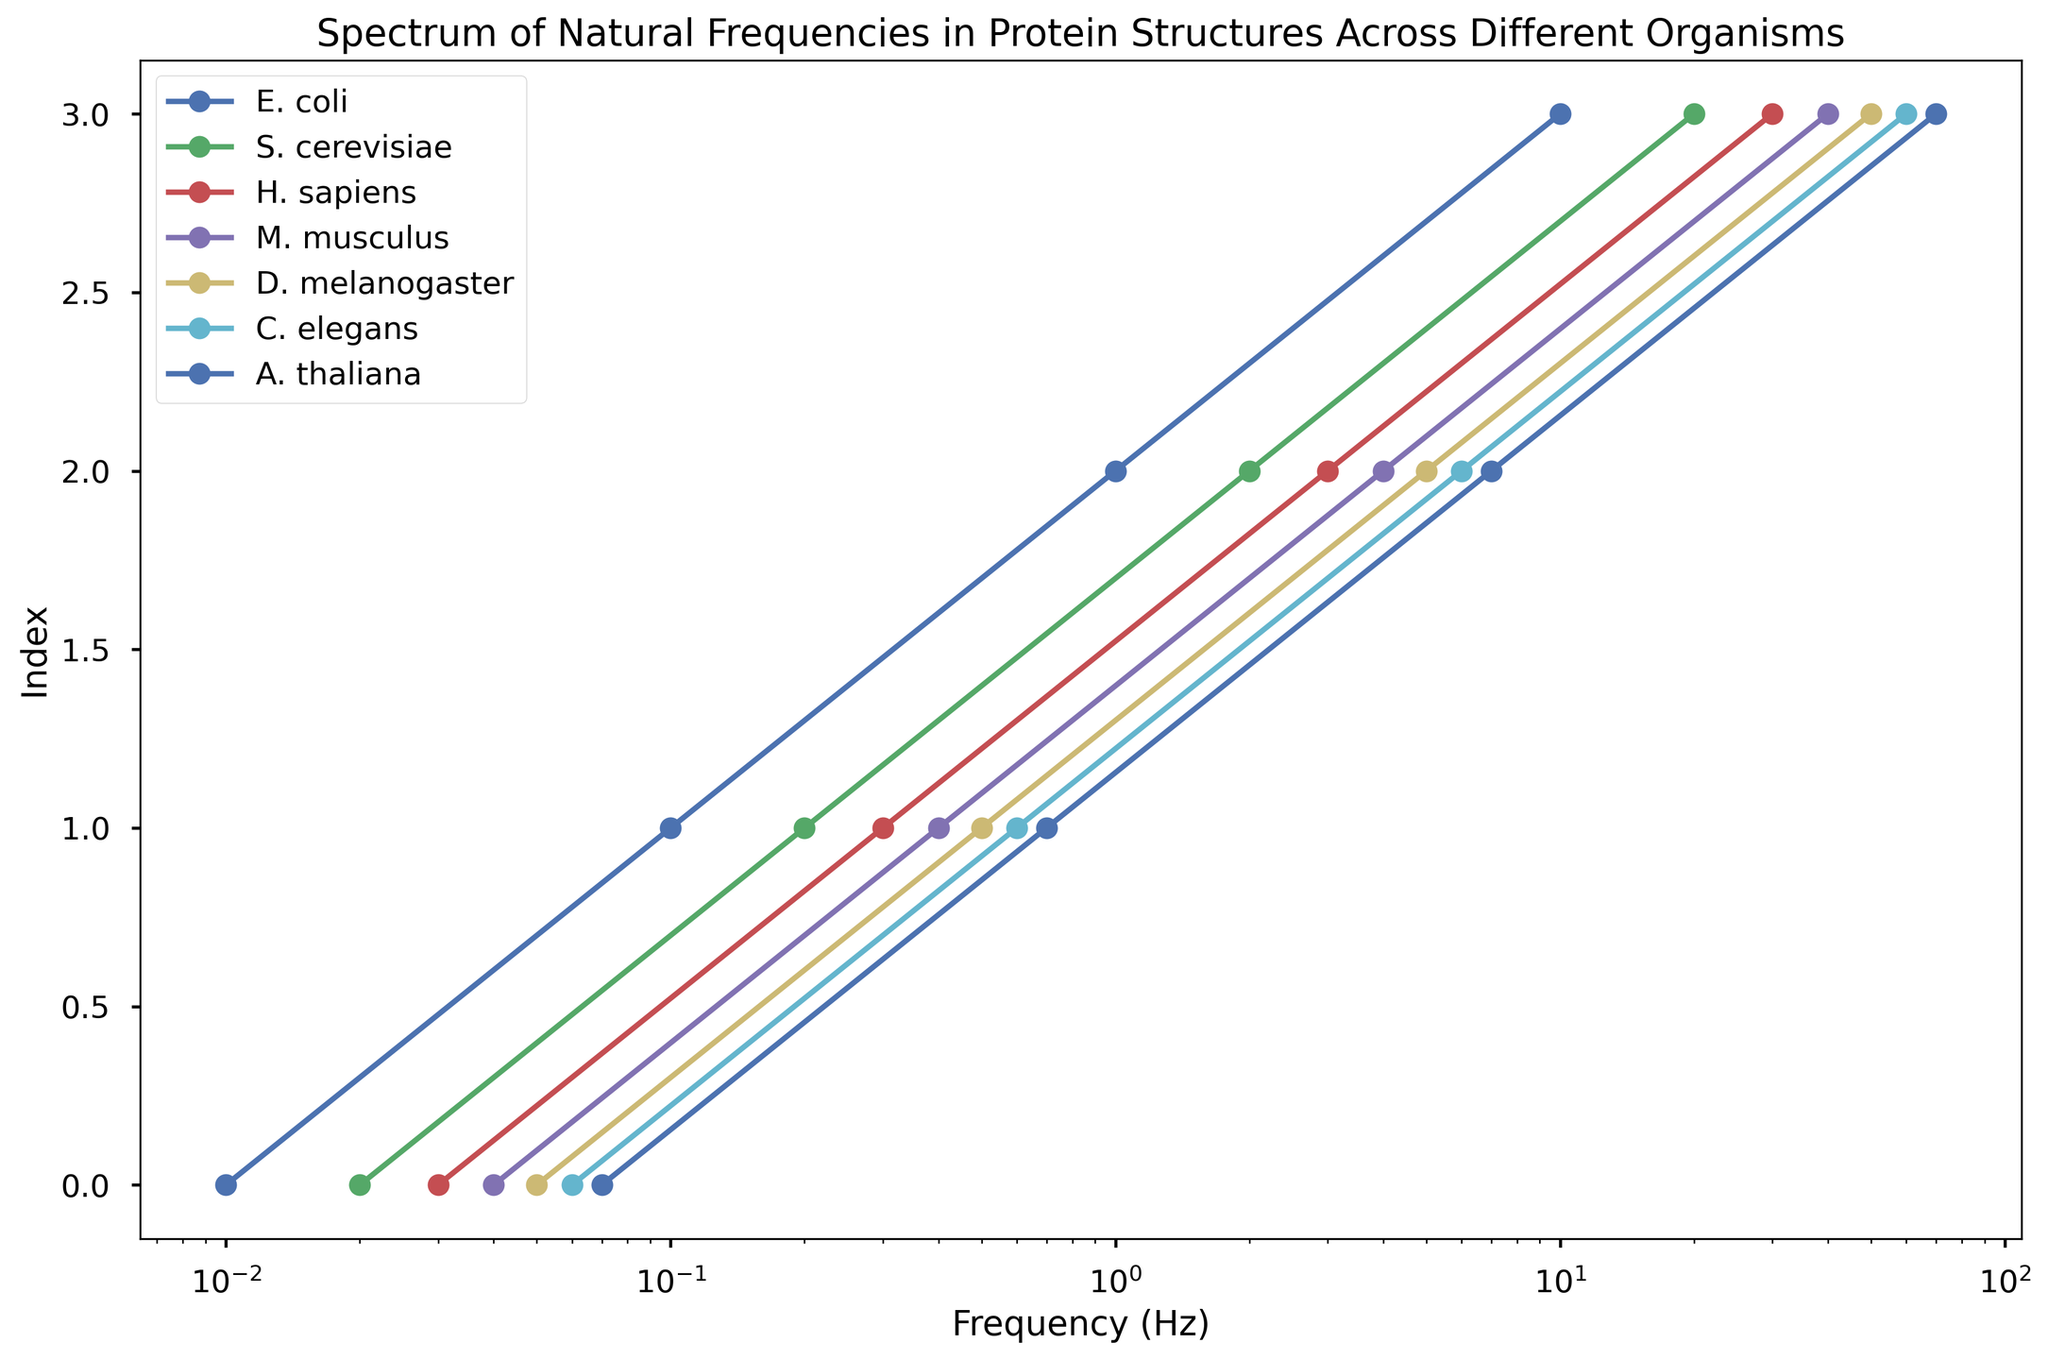Which organism has the highest frequency value represented in the plot? Identify the curves for each organism on the plot and find the one that reaches the highest frequency value on the x-axis. D. melanogaster's plot reaches the highest value at 50 Hz.
Answer: D. melanogaster Which two organisms have frequencies that differ the most at their highest values? Compare the highest frequency values for all organisms plotted on the x-axis. D. melanogaster and A. thaliana differ the most as their highest values are 50 Hz and 70 Hz respectively, resulting in a difference of 20 Hz.
Answer: D. melanogaster and A. thaliana Do any organisms share the same frequency values on the plot? Inspect the plots for each organism on the graph. E. coli and S. cerevisiae share frequency values at 0.1 Hz and 1 Hz.
Answer: E. coli and S. cerevisiae Which organism's frequency distribution appears most compressed on the log scale? On a logarithmic scale, a compressed distribution will show points closer together. E. coli's distribution appears most compressed as its points are closely situated at 0.01 Hz, 0.1 Hz, 1 Hz, and 10 Hz.
Answer: E. coli Which organism has the least number of frequencies plotted on the graph? Count the number of markers for each organism. Each organism has an equal number of frequencies plotted, i.e., 4 frequencies each.
Answer: None (all equal) Is there any organism whose frequency values increase consistently by the same factor? Examine each organism's frequency values on the x-axis and determine if they increase by a constant multiplicative factor. E. coli’s values increase by a factor of 10 (0.01, 0.1, 1, 10).
Answer: E. coli Between S. cerevisiae and C. elegans, which organism shows a higher minimum frequency? Compare the minimum frequency values for S. cerevisiae (0.02 Hz) and C. elegans (0.06 Hz). C. elegans has a higher minimum frequency value.
Answer: C. elegans What is the range of frequencies for H. sapiens as observed in the plot? Identify the minimum and maximum frequency values on H. sapiens' plot. The frequencies range from 0.03 Hz to 30 Hz. The range is 30 Hz - 0.03 Hz = 29.97 Hz.
Answer: 29.97 Hz 